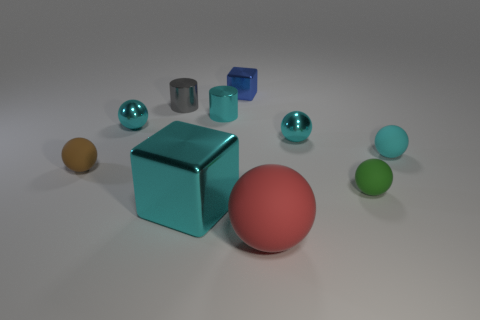Subtract all gray cubes. How many cyan spheres are left? 3 Subtract all tiny green balls. How many balls are left? 5 Subtract 3 spheres. How many spheres are left? 3 Subtract all brown balls. How many balls are left? 5 Subtract all yellow spheres. Subtract all red cylinders. How many spheres are left? 6 Subtract all cylinders. How many objects are left? 8 Subtract 0 green cubes. How many objects are left? 10 Subtract all large metal blocks. Subtract all small green rubber things. How many objects are left? 8 Add 2 tiny blue metal things. How many tiny blue metal things are left? 3 Add 5 blue cubes. How many blue cubes exist? 6 